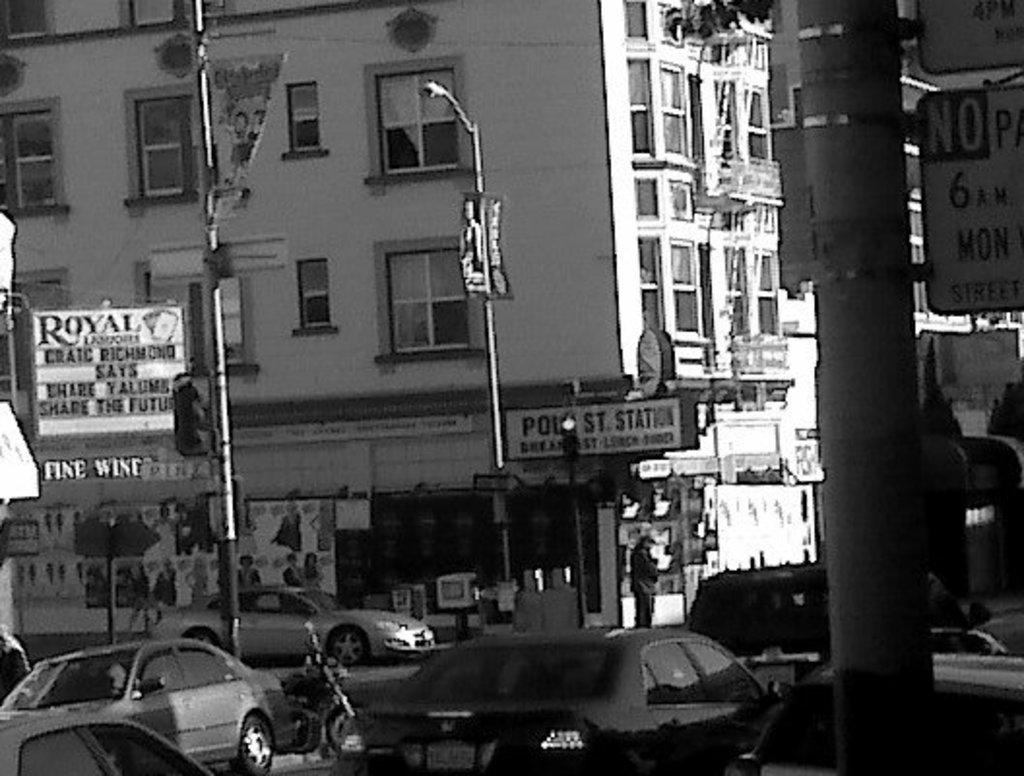What is the color scheme of the image? The image is in black and white. What can be seen on the road in the image? There are vehicles moving on the road. What is attached to the poles in the image? There are boards on the poles. What type of poles are present in the image? There are light poles and traffic signal poles in the image. What can be seen in the background of the image? Buildings are visible in the background. What is the cause of the traffic signal pole at the end of the road? There is no cause mentioned for the traffic signal pole in the image, as it is simply a part of the road infrastructure. How many steps are required to reach the light pole in the image? The image is a still photograph, so it is not possible to determine the number of steps required to reach the light pole. 